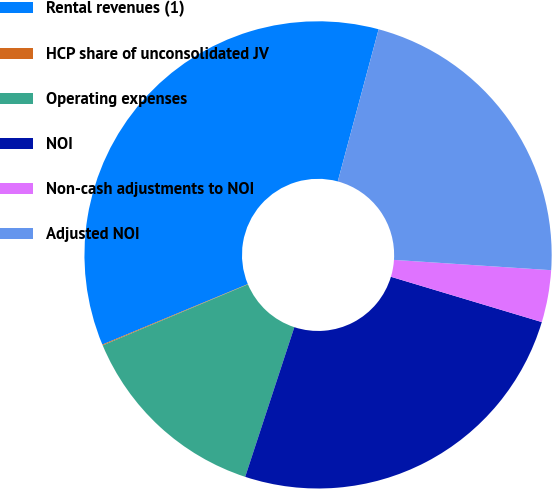<chart> <loc_0><loc_0><loc_500><loc_500><pie_chart><fcel>Rental revenues (1)<fcel>HCP share of unconsolidated JV<fcel>Operating expenses<fcel>NOI<fcel>Non-cash adjustments to NOI<fcel>Adjusted NOI<nl><fcel>35.45%<fcel>0.06%<fcel>13.62%<fcel>25.41%<fcel>3.6%<fcel>21.87%<nl></chart> 